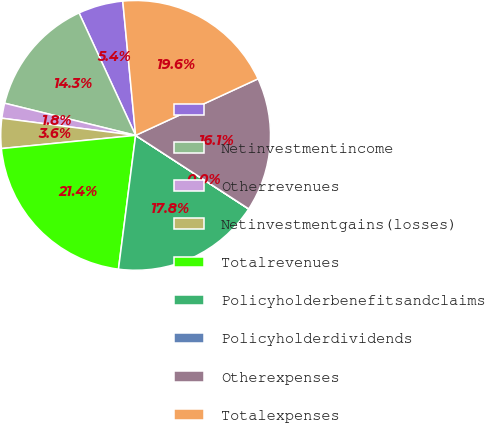<chart> <loc_0><loc_0><loc_500><loc_500><pie_chart><ecel><fcel>Netinvestmentincome<fcel>Otherrevenues<fcel>Netinvestmentgains(losses)<fcel>Totalrevenues<fcel>Policyholderbenefitsandclaims<fcel>Policyholderdividends<fcel>Otherexpenses<fcel>Totalexpenses<nl><fcel>5.37%<fcel>14.28%<fcel>1.8%<fcel>3.59%<fcel>21.41%<fcel>17.84%<fcel>0.02%<fcel>16.06%<fcel>19.63%<nl></chart> 